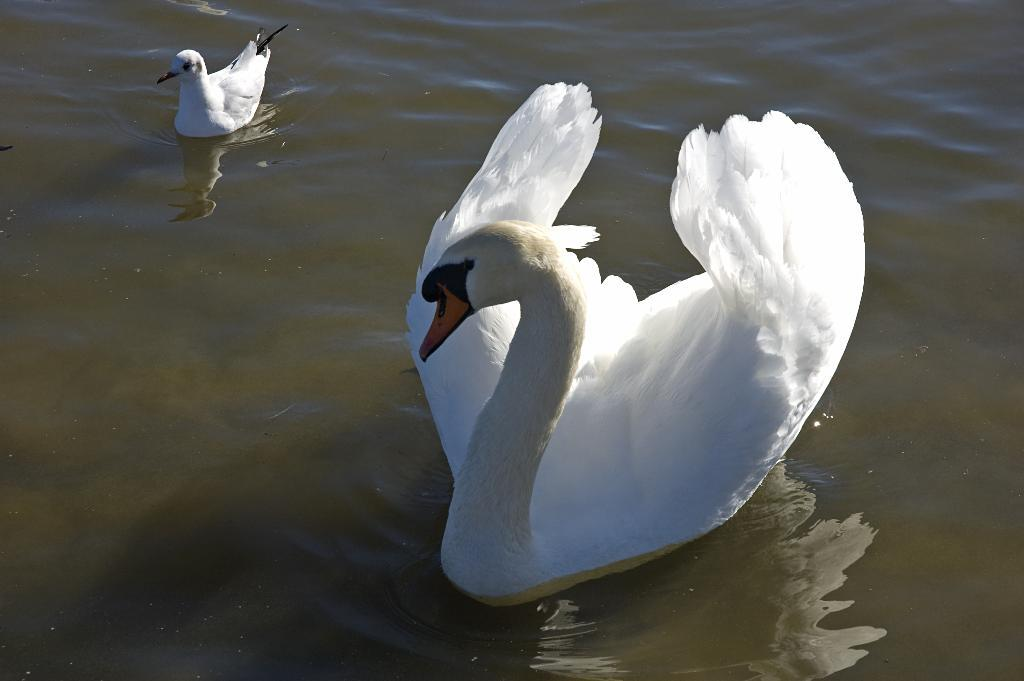What animals are present in the image? There are two swans in the image. What color are the swans? The swans are white in color. What are the swans doing in the image? The swans are swimming in the water. What type of industry can be seen in the background of the image? There is no industry present in the image; it features two white swans swimming in the water. What is the swans using to carry their belongings in the image? There is no tray or any indication of the swans carrying belongings in the image. 